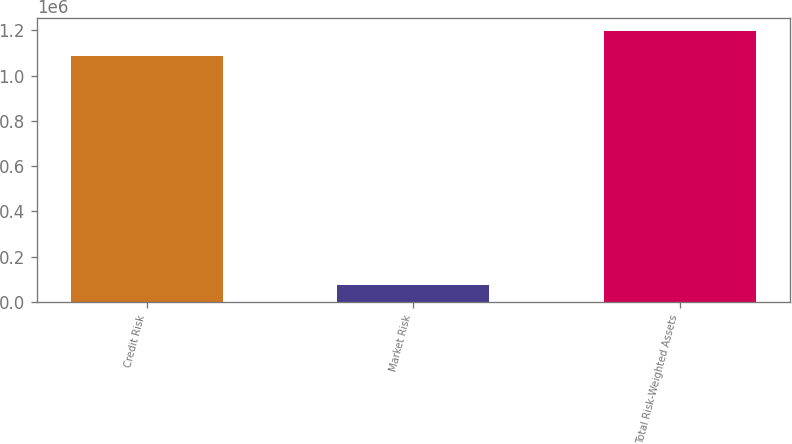Convert chart to OTSL. <chart><loc_0><loc_0><loc_500><loc_500><bar_chart><fcel>Credit Risk<fcel>Market Risk<fcel>Total Risk-Weighted Assets<nl><fcel>1.0877e+06<fcel>75185<fcel>1.19647e+06<nl></chart> 